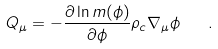Convert formula to latex. <formula><loc_0><loc_0><loc_500><loc_500>Q _ { \mu } = - \frac { \partial \ln m ( \phi ) } { \partial \phi } \rho _ { c } \nabla _ { \mu } \phi \quad .</formula> 